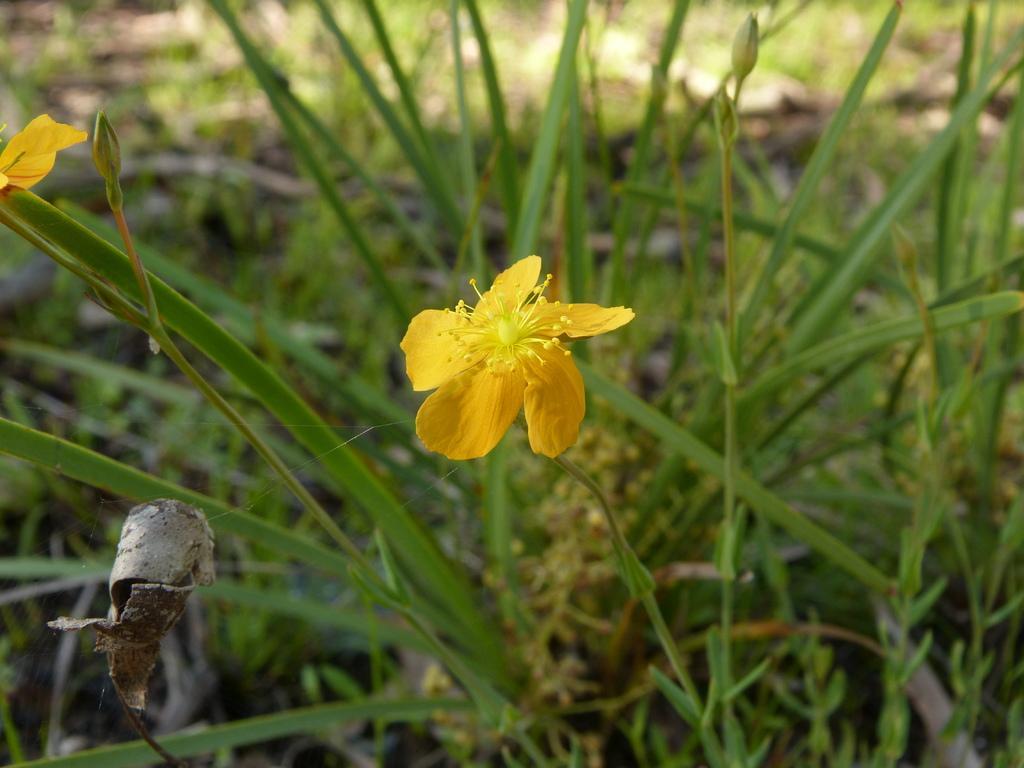Describe this image in one or two sentences. In this picture we can see a yellow flower and few green plants in the background. 